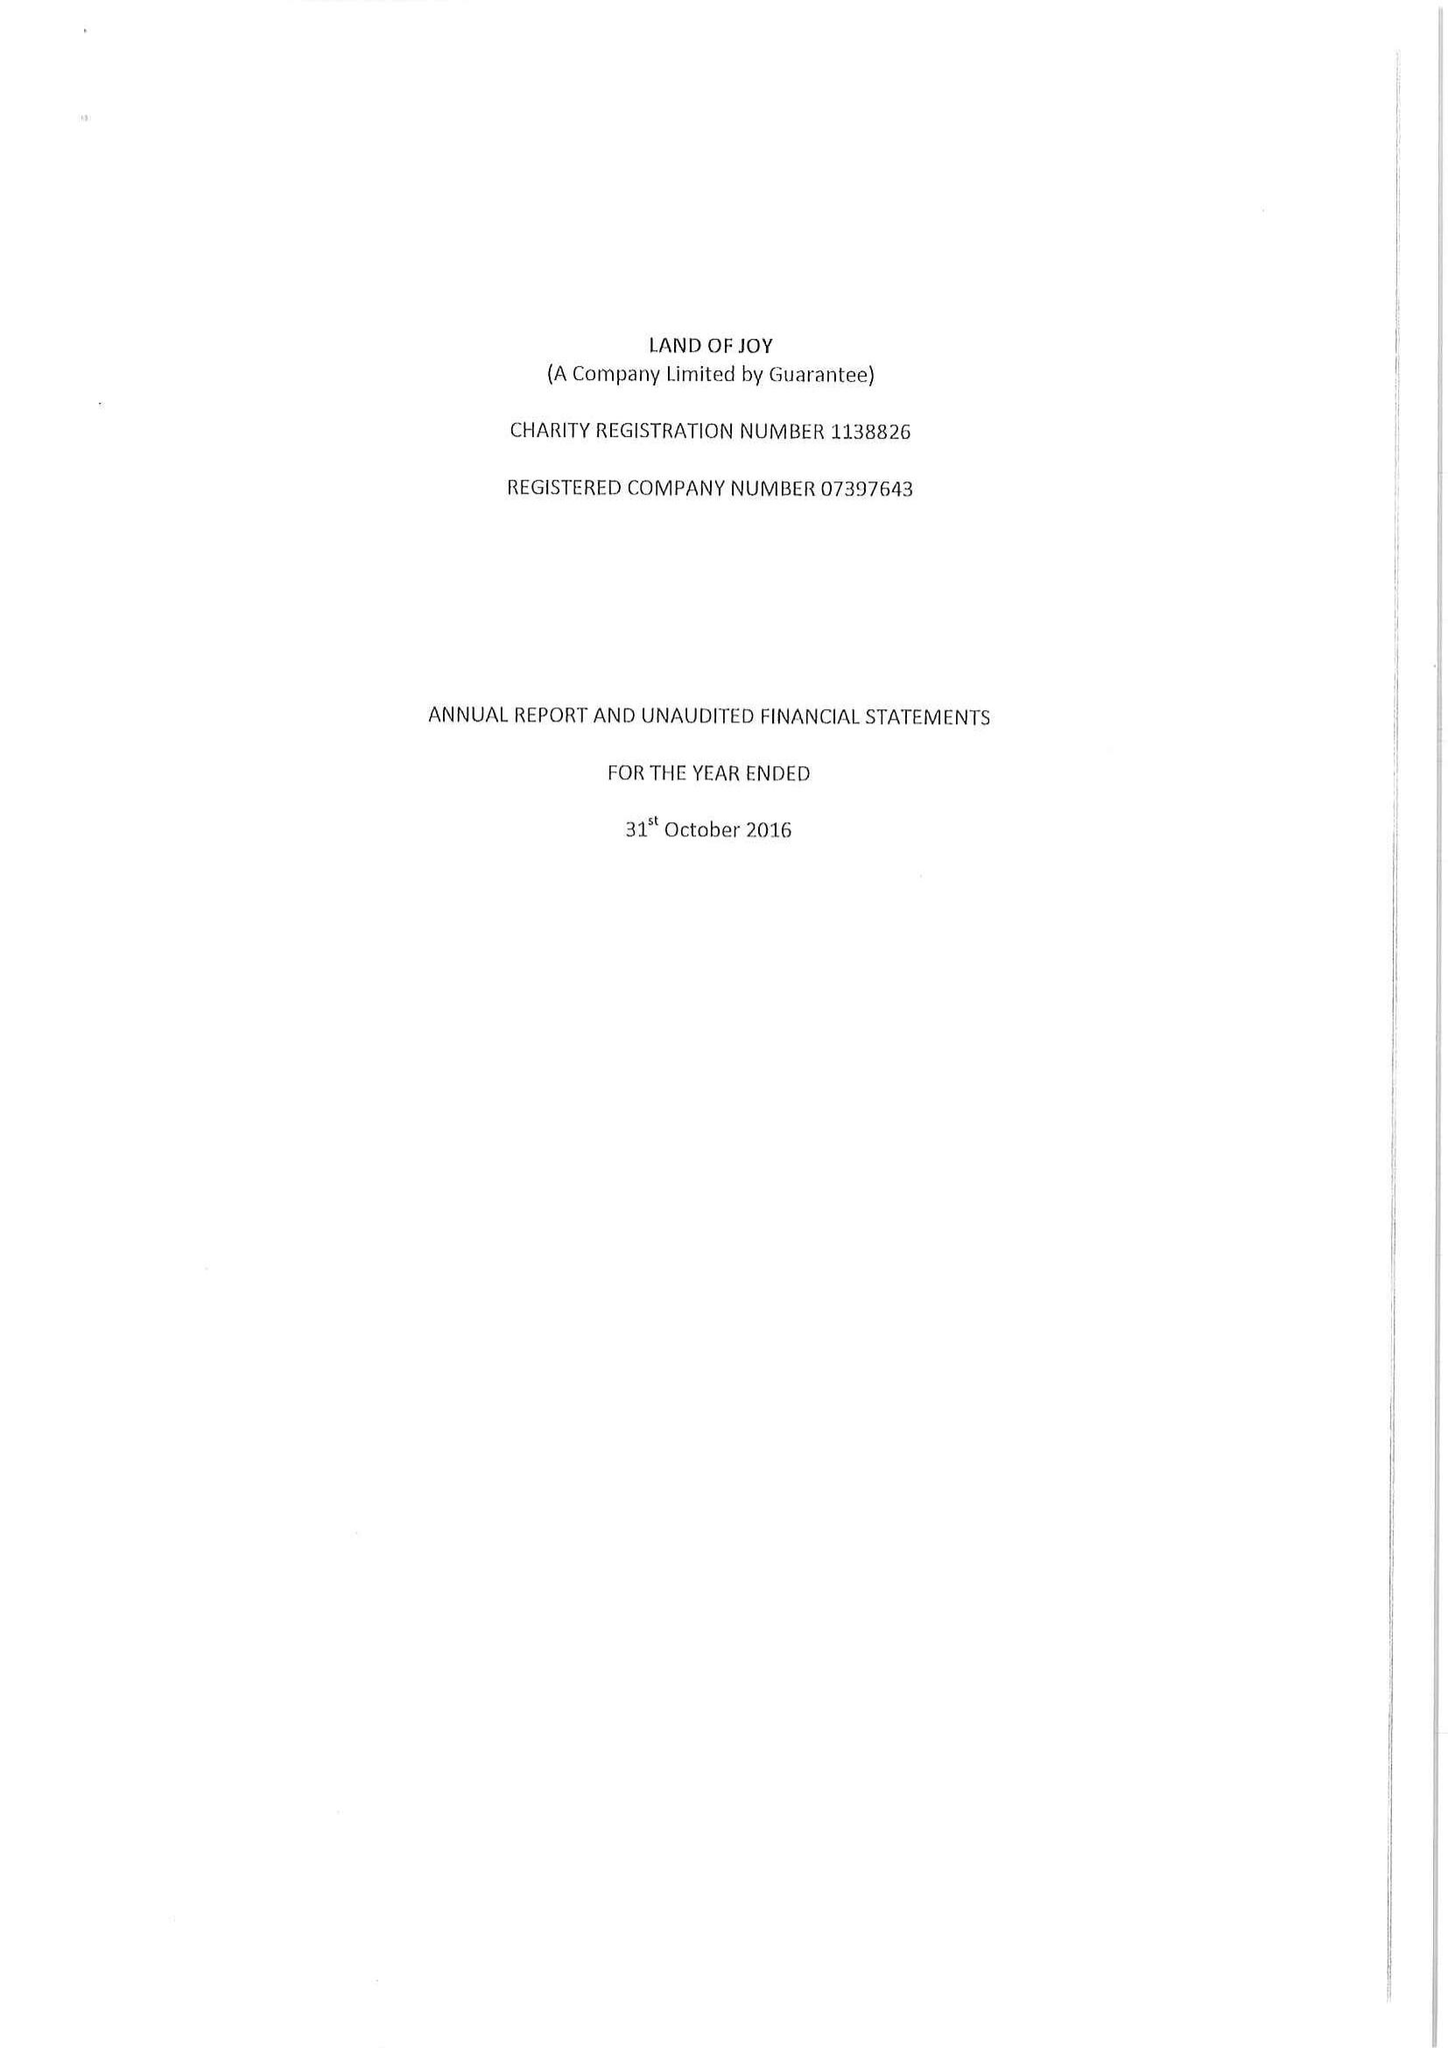What is the value for the charity_name?
Answer the question using a single word or phrase. Land Of Joy 